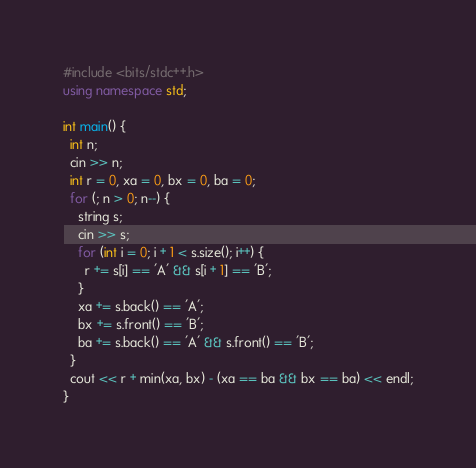<code> <loc_0><loc_0><loc_500><loc_500><_C++_>#include <bits/stdc++.h>
using namespace std;

int main() {
  int n;
  cin >> n;
  int r = 0, xa = 0, bx = 0, ba = 0;
  for (; n > 0; n--) {
    string s;
    cin >> s;
    for (int i = 0; i + 1 < s.size(); i++) {
      r += s[i] == 'A' && s[i + 1] == 'B';
    }
    xa += s.back() == 'A';
    bx += s.front() == 'B';
    ba += s.back() == 'A' && s.front() == 'B';
  }
  cout << r + min(xa, bx) - (xa == ba && bx == ba) << endl;
}
</code> 